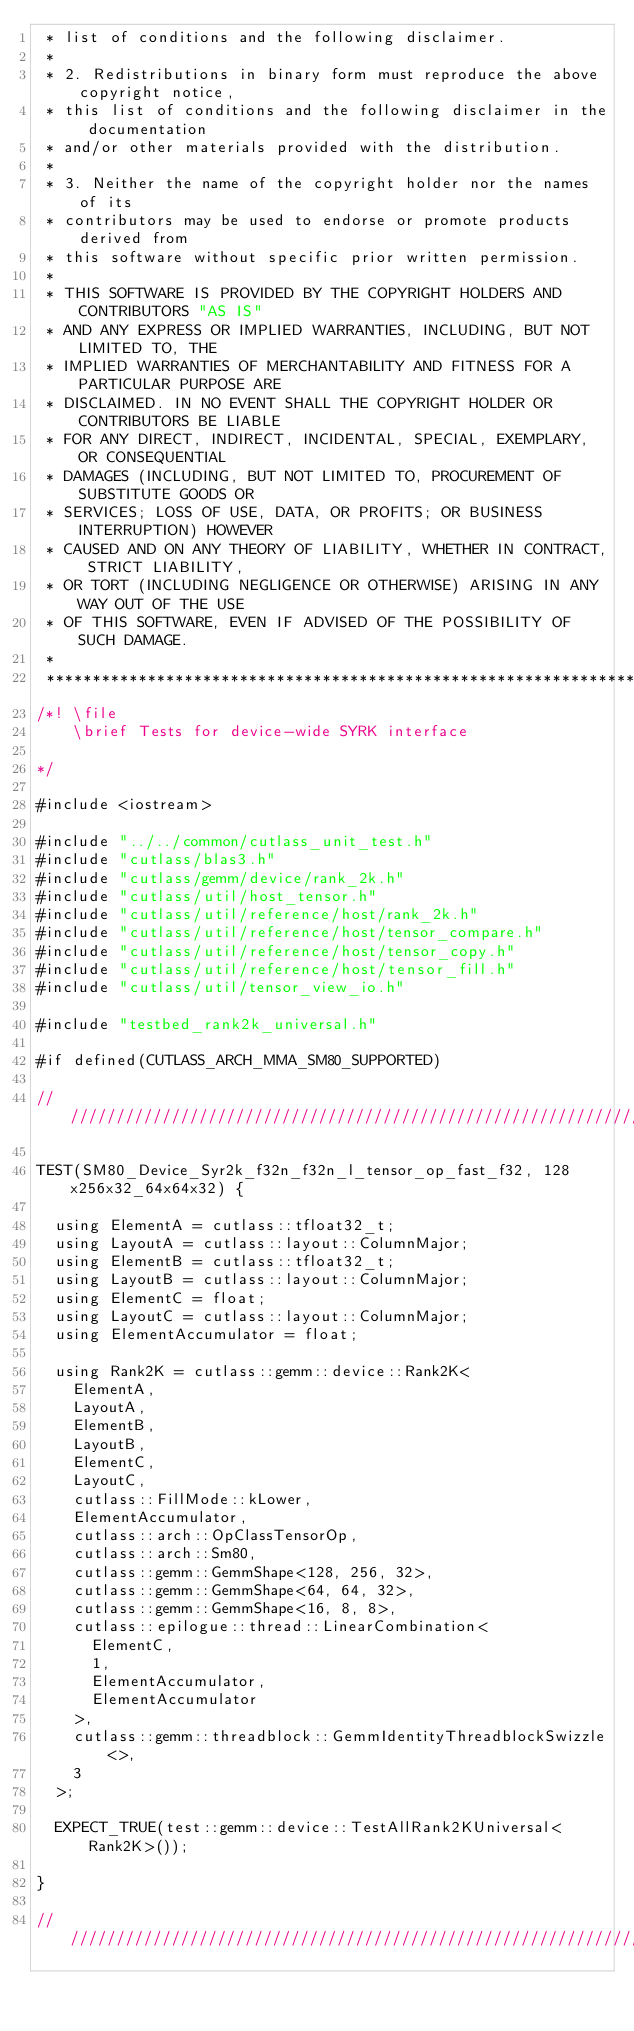<code> <loc_0><loc_0><loc_500><loc_500><_Cuda_> * list of conditions and the following disclaimer.
 *
 * 2. Redistributions in binary form must reproduce the above copyright notice,
 * this list of conditions and the following disclaimer in the documentation
 * and/or other materials provided with the distribution.
 *
 * 3. Neither the name of the copyright holder nor the names of its
 * contributors may be used to endorse or promote products derived from
 * this software without specific prior written permission.
 *
 * THIS SOFTWARE IS PROVIDED BY THE COPYRIGHT HOLDERS AND CONTRIBUTORS "AS IS"
 * AND ANY EXPRESS OR IMPLIED WARRANTIES, INCLUDING, BUT NOT LIMITED TO, THE
 * IMPLIED WARRANTIES OF MERCHANTABILITY AND FITNESS FOR A PARTICULAR PURPOSE ARE
 * DISCLAIMED. IN NO EVENT SHALL THE COPYRIGHT HOLDER OR CONTRIBUTORS BE LIABLE
 * FOR ANY DIRECT, INDIRECT, INCIDENTAL, SPECIAL, EXEMPLARY, OR CONSEQUENTIAL
 * DAMAGES (INCLUDING, BUT NOT LIMITED TO, PROCUREMENT OF SUBSTITUTE GOODS OR
 * SERVICES; LOSS OF USE, DATA, OR PROFITS; OR BUSINESS INTERRUPTION) HOWEVER
 * CAUSED AND ON ANY THEORY OF LIABILITY, WHETHER IN CONTRACT, STRICT LIABILITY,
 * OR TORT (INCLUDING NEGLIGENCE OR OTHERWISE) ARISING IN ANY WAY OUT OF THE USE
 * OF THIS SOFTWARE, EVEN IF ADVISED OF THE POSSIBILITY OF SUCH DAMAGE.
 *
 **************************************************************************************************/
/*! \file
    \brief Tests for device-wide SYRK interface
  
*/

#include <iostream>

#include "../../common/cutlass_unit_test.h"
#include "cutlass/blas3.h"
#include "cutlass/gemm/device/rank_2k.h"
#include "cutlass/util/host_tensor.h"
#include "cutlass/util/reference/host/rank_2k.h"
#include "cutlass/util/reference/host/tensor_compare.h"
#include "cutlass/util/reference/host/tensor_copy.h"
#include "cutlass/util/reference/host/tensor_fill.h"
#include "cutlass/util/tensor_view_io.h"

#include "testbed_rank2k_universal.h"

#if defined(CUTLASS_ARCH_MMA_SM80_SUPPORTED)

/////////////////////////////////////////////////////////////////////////////////////////////////

TEST(SM80_Device_Syr2k_f32n_f32n_l_tensor_op_fast_f32, 128x256x32_64x64x32) {

  using ElementA = cutlass::tfloat32_t;
  using LayoutA = cutlass::layout::ColumnMajor;
  using ElementB = cutlass::tfloat32_t;
  using LayoutB = cutlass::layout::ColumnMajor;
  using ElementC = float;
  using LayoutC = cutlass::layout::ColumnMajor;
  using ElementAccumulator = float;

  using Rank2K = cutlass::gemm::device::Rank2K<
    ElementA,
    LayoutA,
    ElementB,
    LayoutB,
    ElementC,
    LayoutC,
    cutlass::FillMode::kLower,
    ElementAccumulator,
    cutlass::arch::OpClassTensorOp,
    cutlass::arch::Sm80,
    cutlass::gemm::GemmShape<128, 256, 32>,
    cutlass::gemm::GemmShape<64, 64, 32>,
    cutlass::gemm::GemmShape<16, 8, 8>,
    cutlass::epilogue::thread::LinearCombination<
      ElementC,
      1,
      ElementAccumulator,
      ElementAccumulator
    >,
    cutlass::gemm::threadblock::GemmIdentityThreadblockSwizzle<>,
    3
  >;

  EXPECT_TRUE(test::gemm::device::TestAllRank2KUniversal<Rank2K>());

}

/////////////////////////////////////////////////////////////////////////////////////////////////
</code> 